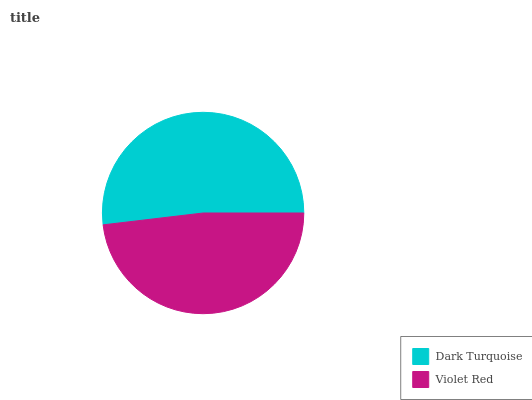Is Violet Red the minimum?
Answer yes or no. Yes. Is Dark Turquoise the maximum?
Answer yes or no. Yes. Is Violet Red the maximum?
Answer yes or no. No. Is Dark Turquoise greater than Violet Red?
Answer yes or no. Yes. Is Violet Red less than Dark Turquoise?
Answer yes or no. Yes. Is Violet Red greater than Dark Turquoise?
Answer yes or no. No. Is Dark Turquoise less than Violet Red?
Answer yes or no. No. Is Dark Turquoise the high median?
Answer yes or no. Yes. Is Violet Red the low median?
Answer yes or no. Yes. Is Violet Red the high median?
Answer yes or no. No. Is Dark Turquoise the low median?
Answer yes or no. No. 